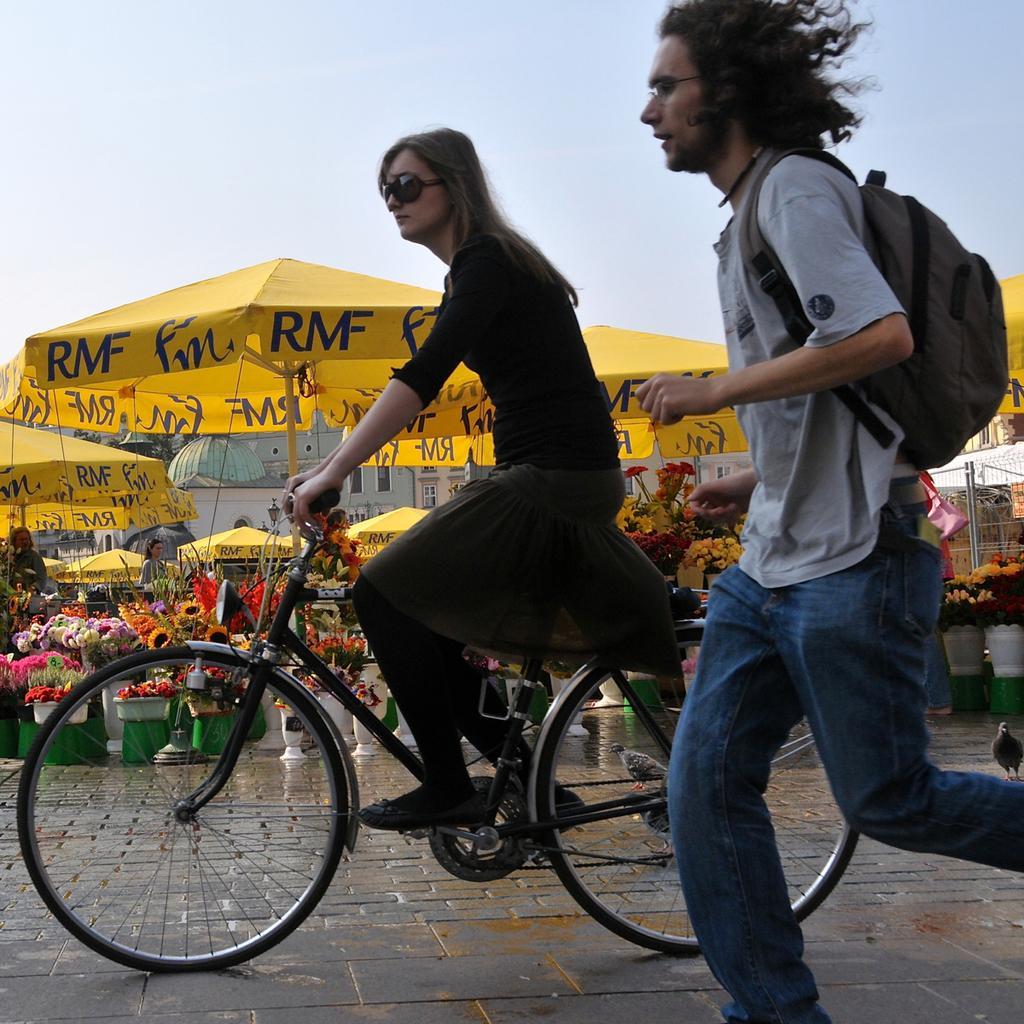Please provide a concise description of this image. At the top of the picture we can see a sky. Here we can see umbrellas in yellow colour. These are flower pots on the floor. Here we can see one man wearing backpack running on the road. We can see one woman riding a bicycle. She wore goggles. 